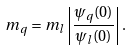Convert formula to latex. <formula><loc_0><loc_0><loc_500><loc_500>m _ { q } = m _ { l } \left | \frac { \psi _ { q } ( 0 ) } { \psi _ { l } ( 0 ) } \right | .</formula> 